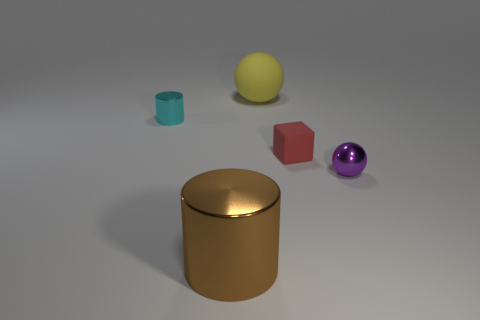Can you infer what material the yellow object is likely made of? Though it's difficult to determine the exact material without additional context, the yellow object appears to have a slightly matte finish which suggests it could be made of plastic, rubber, or perhaps a coated metal, if we're considering its ability to cast a soft shadow and its slight reflection.  Is there a relationship between the shapes and colors of the objects? There doesn't seem to be a specific relationship between the shapes and colors of the objects in terms of a pattern or theme. However, the variety in shapes and colors could suggest a deliberate choice to represent diversity or contrast within a unifying context, such as a visualization of geometric shapes or a color study. 